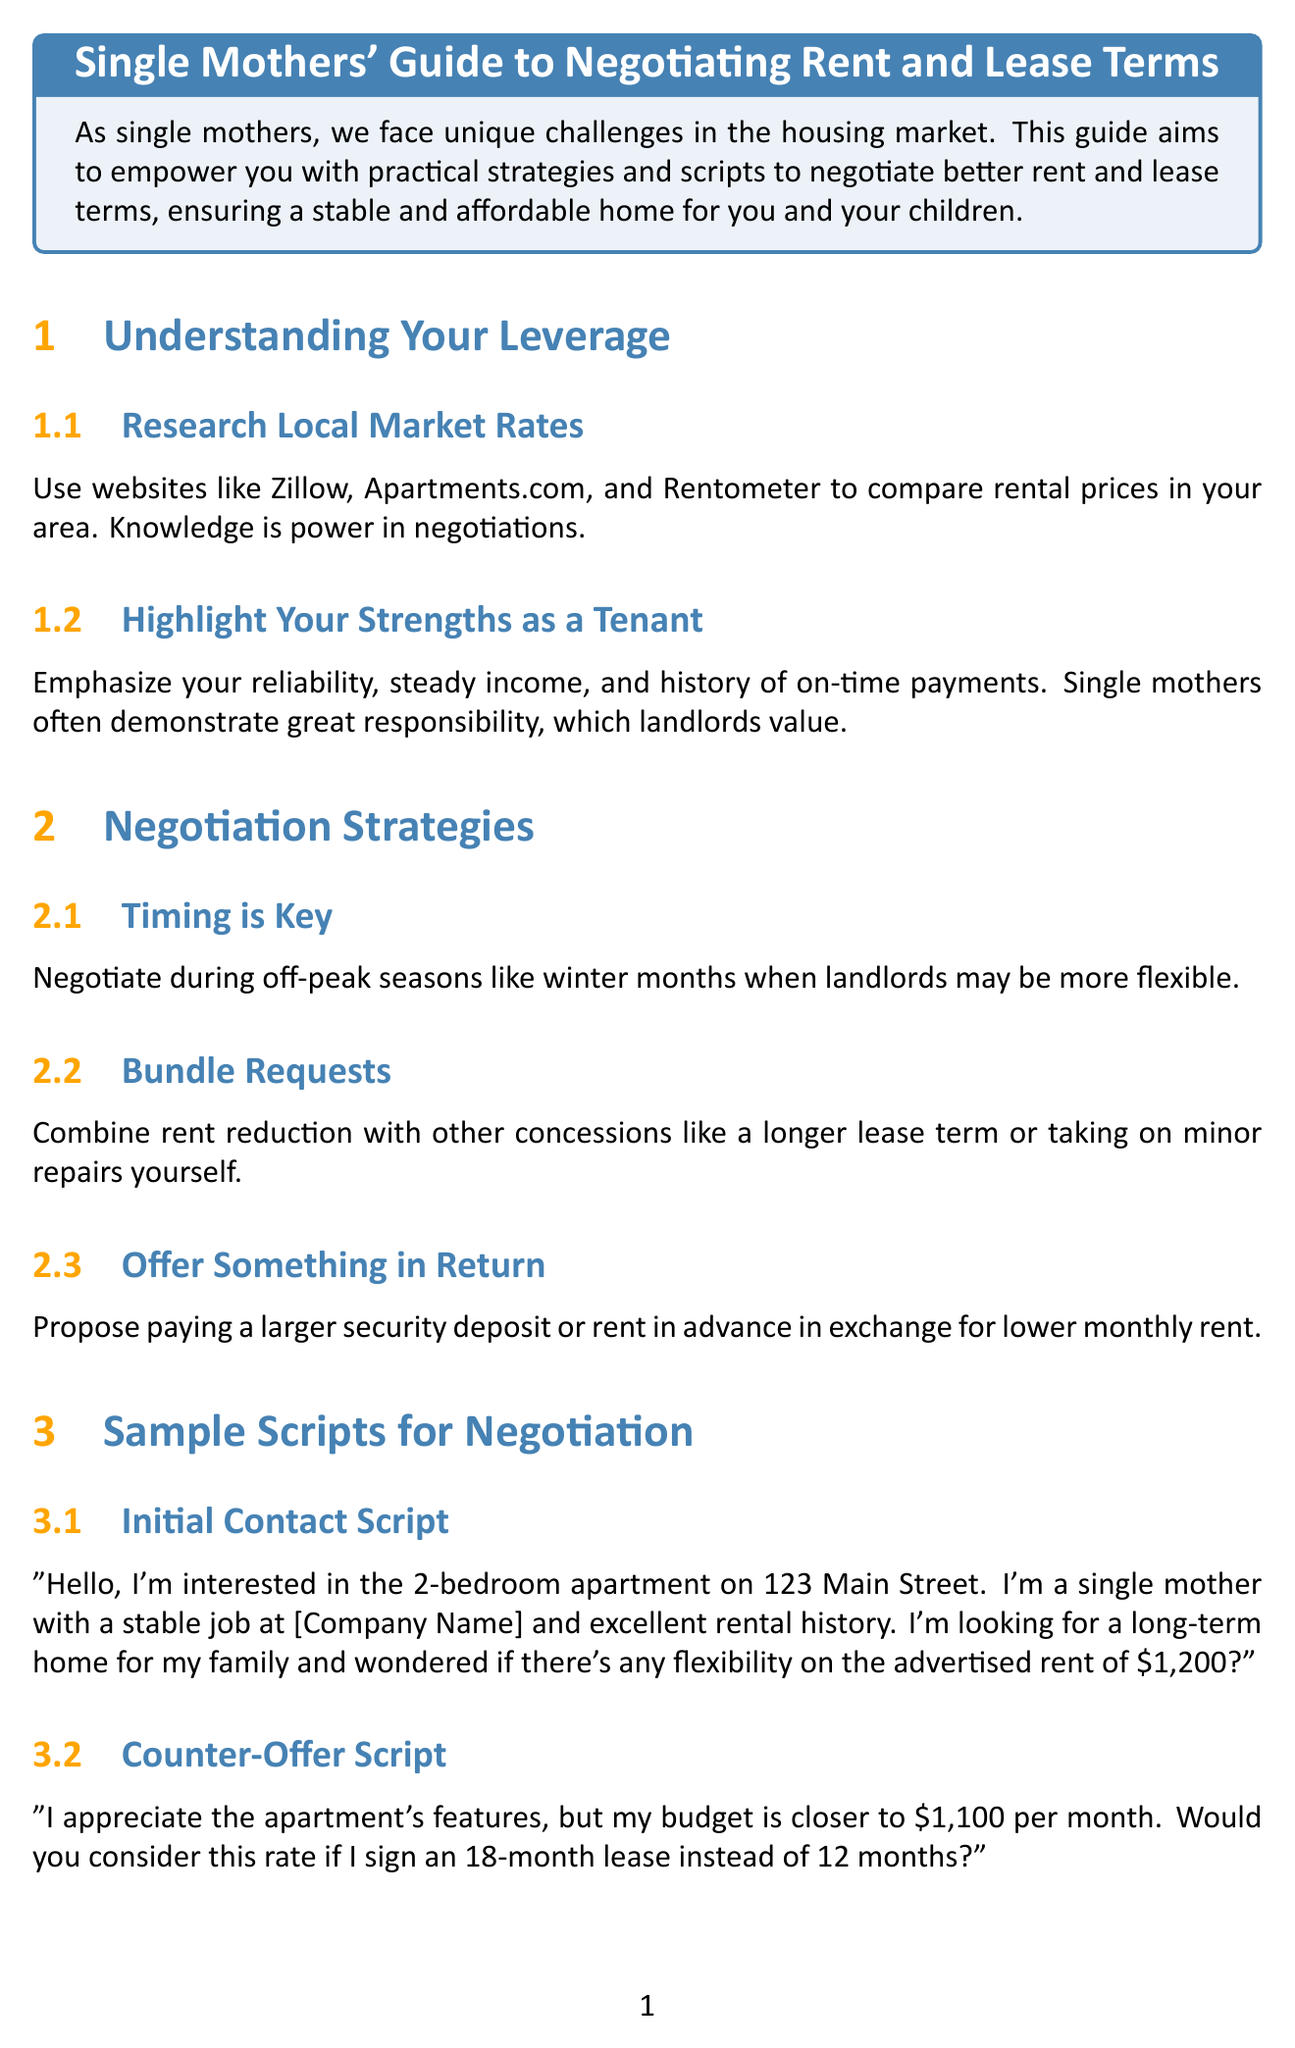What is the title of the guide? The title is explicitly stated at the beginning of the document.
Answer: Single Mothers' Guide to Negotiating Rent and Lease Terms What websites are suggested for researching local market rates? The document lists specific websites to compare rental prices in the local market.
Answer: Zillow, Apartments.com, and Rentometer What should you negotiate during off-peak seasons? This content specifies the timing strategy for negotiations.
Answer: Rent What is one option to propose in exchange for lower monthly rent? The section outlines a strategy on what to offer in return during negotiations.
Answer: Larger security deposit Which government assistance program is mentioned for negotiating leverage? The document includes specific programs that can be used as leverage with landlords.
Answer: Section 8 Housing Choice Voucher Program What group can single mothers join for support? This information is found in the section about building a support network.
Answer: Single Moms Housing Network What type of clause should be negotiated for early termination? The document recommends a specific clause for lease negotiations.
Answer: Early termination clause What is a potential responsibility you may negotiate with your landlord? The lease term section discusses maintenance responsibilities that can be clarified.
Answer: Minor repairs 